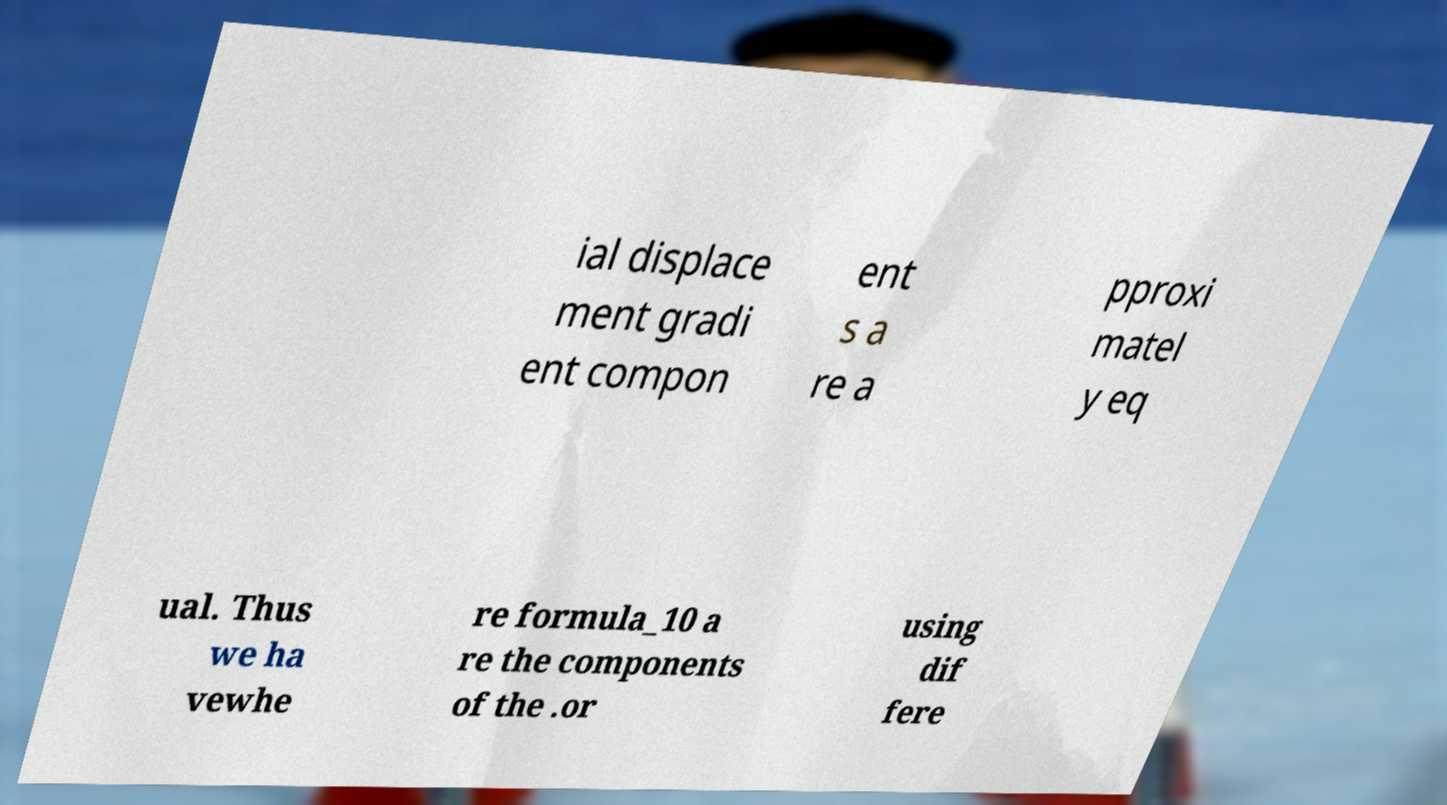There's text embedded in this image that I need extracted. Can you transcribe it verbatim? ial displace ment gradi ent compon ent s a re a pproxi matel y eq ual. Thus we ha vewhe re formula_10 a re the components of the .or using dif fere 